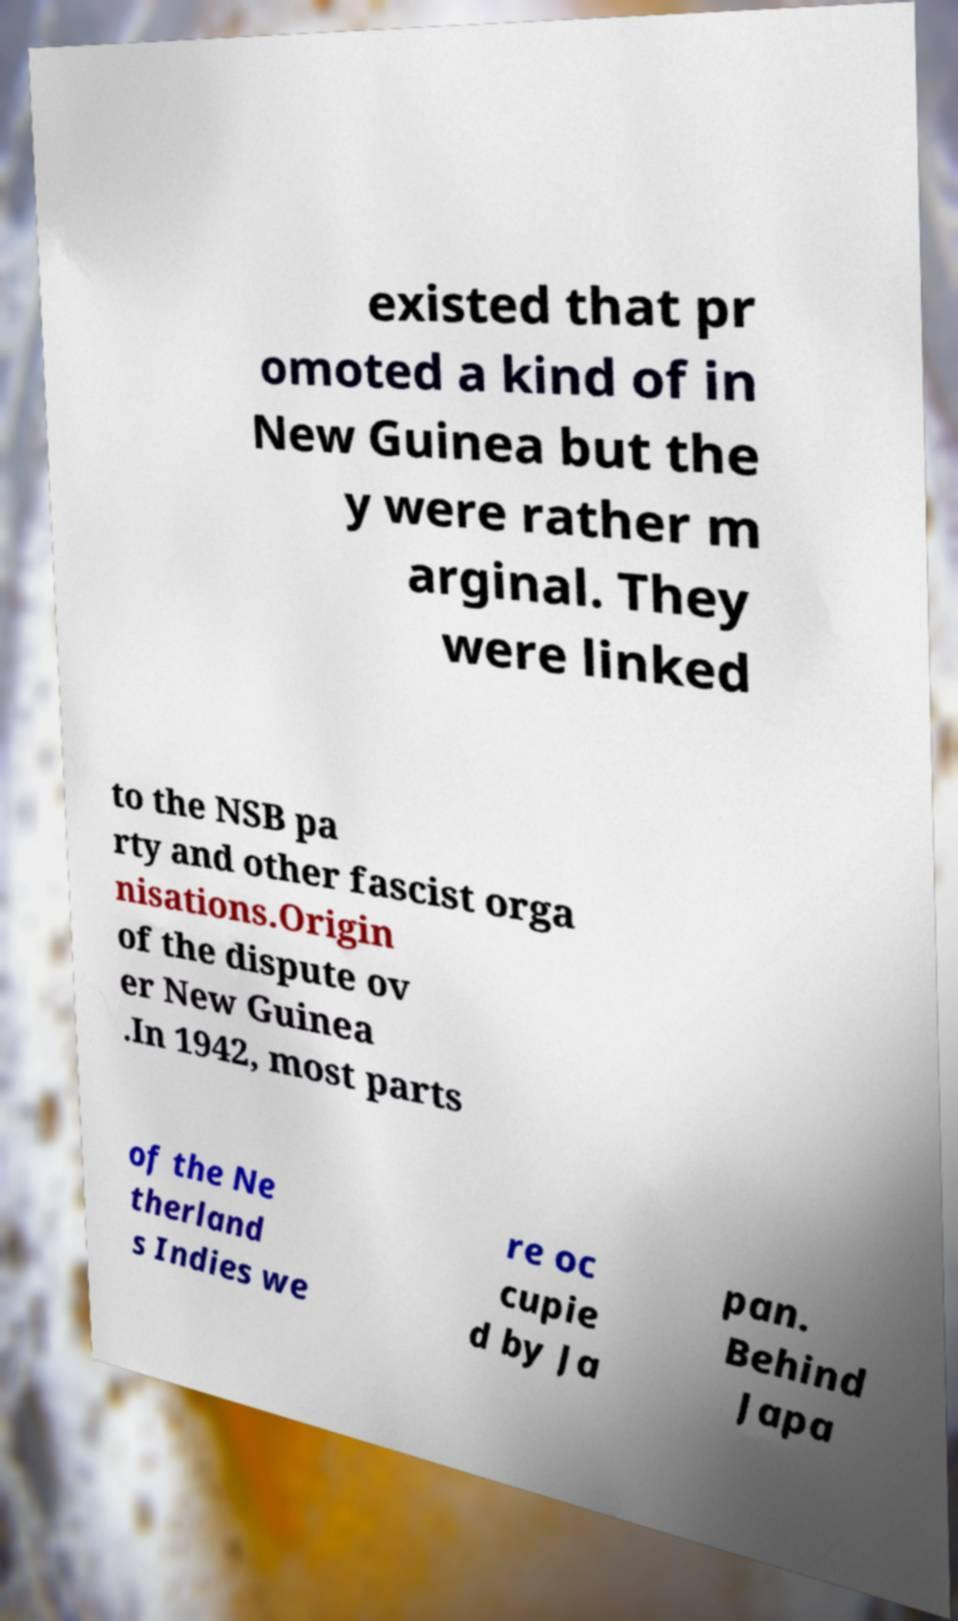There's text embedded in this image that I need extracted. Can you transcribe it verbatim? existed that pr omoted a kind of in New Guinea but the y were rather m arginal. They were linked to the NSB pa rty and other fascist orga nisations.Origin of the dispute ov er New Guinea .In 1942, most parts of the Ne therland s Indies we re oc cupie d by Ja pan. Behind Japa 